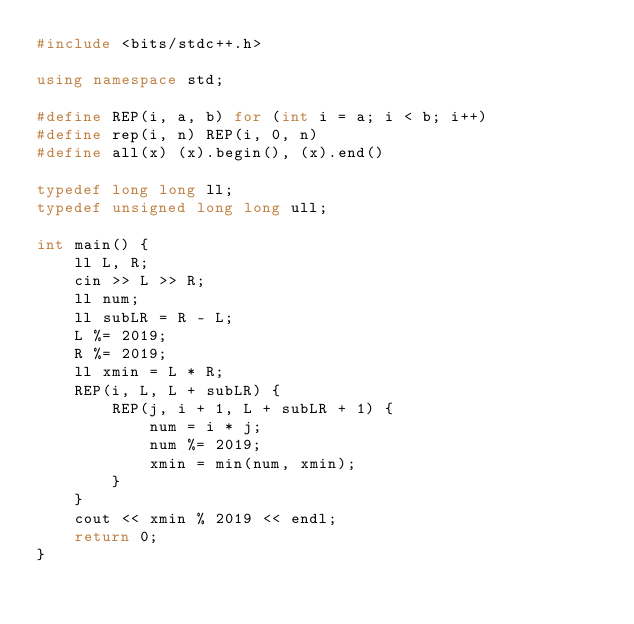Convert code to text. <code><loc_0><loc_0><loc_500><loc_500><_C++_>#include <bits/stdc++.h>

using namespace std;

#define REP(i, a, b) for (int i = a; i < b; i++)
#define rep(i, n) REP(i, 0, n)
#define all(x) (x).begin(), (x).end()

typedef long long ll;
typedef unsigned long long ull;

int main() {
    ll L, R;
    cin >> L >> R;
    ll num;
    ll subLR = R - L;
    L %= 2019;
    R %= 2019;
    ll xmin = L * R;
    REP(i, L, L + subLR) {
        REP(j, i + 1, L + subLR + 1) {
            num = i * j;
            num %= 2019;
            xmin = min(num, xmin);
        }
    }
    cout << xmin % 2019 << endl;
    return 0;
}</code> 